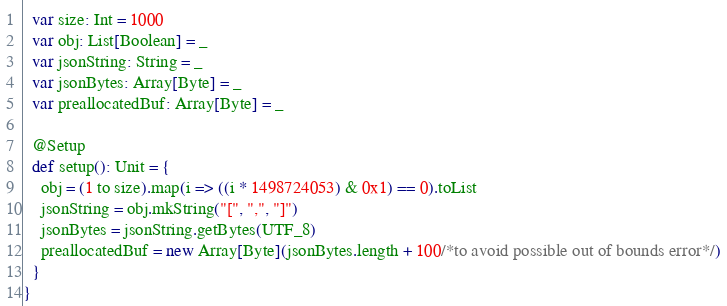<code> <loc_0><loc_0><loc_500><loc_500><_Scala_>  var size: Int = 1000
  var obj: List[Boolean] = _
  var jsonString: String = _
  var jsonBytes: Array[Byte] = _
  var preallocatedBuf: Array[Byte] = _

  @Setup
  def setup(): Unit = {
    obj = (1 to size).map(i => ((i * 1498724053) & 0x1) == 0).toList
    jsonString = obj.mkString("[", ",", "]")
    jsonBytes = jsonString.getBytes(UTF_8)
    preallocatedBuf = new Array[Byte](jsonBytes.length + 100/*to avoid possible out of bounds error*/)
  }
}</code> 